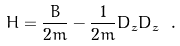<formula> <loc_0><loc_0><loc_500><loc_500>H = \frac { B } { 2 m } - \frac { 1 } { 2 m } D _ { z } D _ { \bar { z } } \ .</formula> 